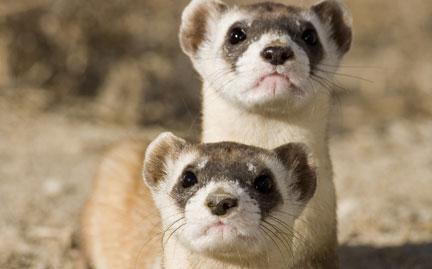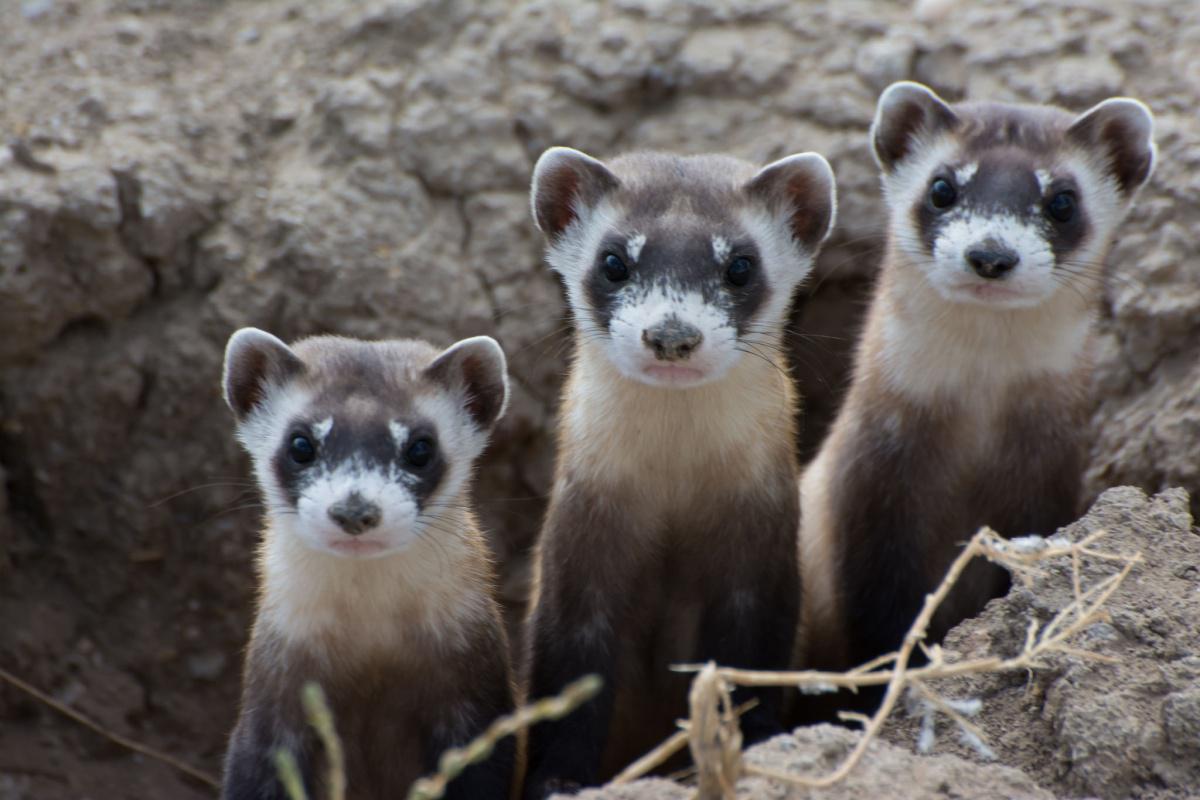The first image is the image on the left, the second image is the image on the right. Analyze the images presented: Is the assertion "Three prairie dogs are poking their heads out of the ground in one of the images." valid? Answer yes or no. Yes. 